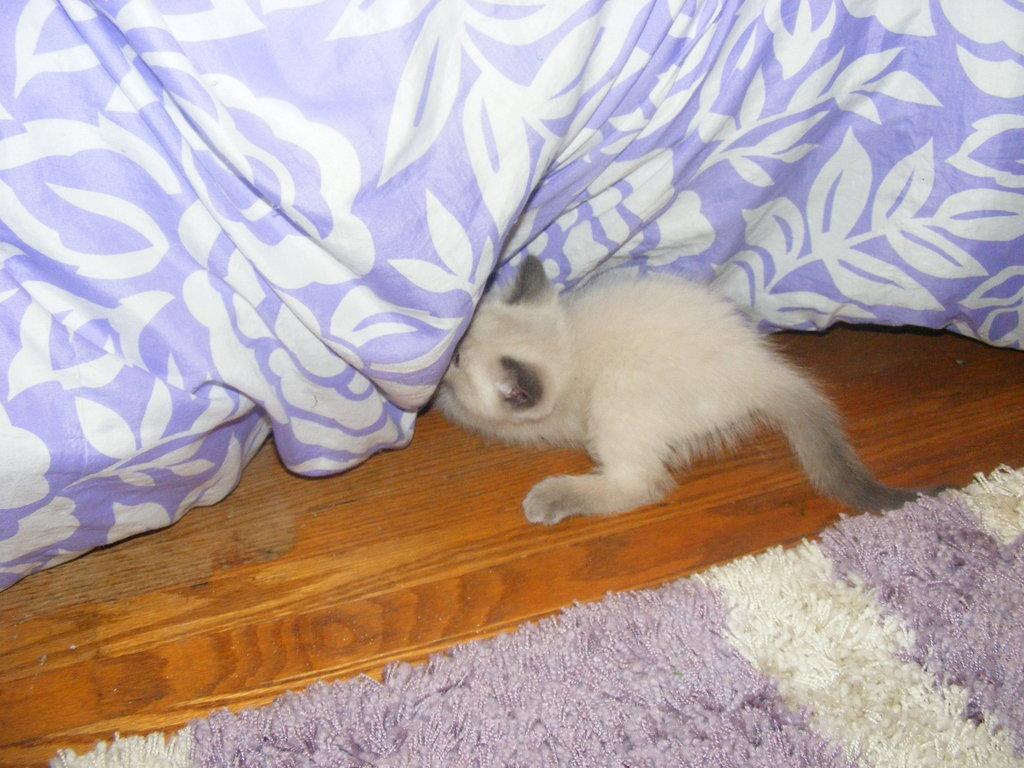How would you summarize this image in a sentence or two? In this image we can see an animal, bed sheet and mat are on a platform. 